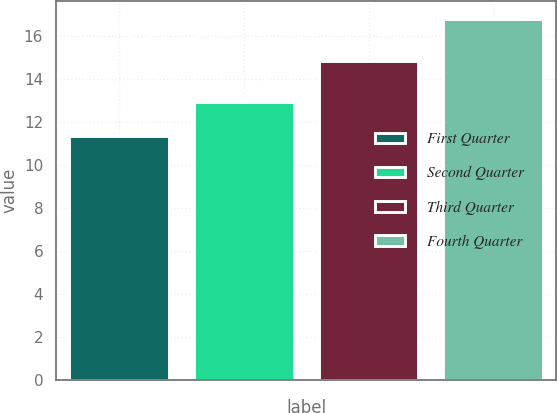<chart> <loc_0><loc_0><loc_500><loc_500><bar_chart><fcel>First Quarter<fcel>Second Quarter<fcel>Third Quarter<fcel>Fourth Quarter<nl><fcel>11.35<fcel>12.95<fcel>14.83<fcel>16.8<nl></chart> 